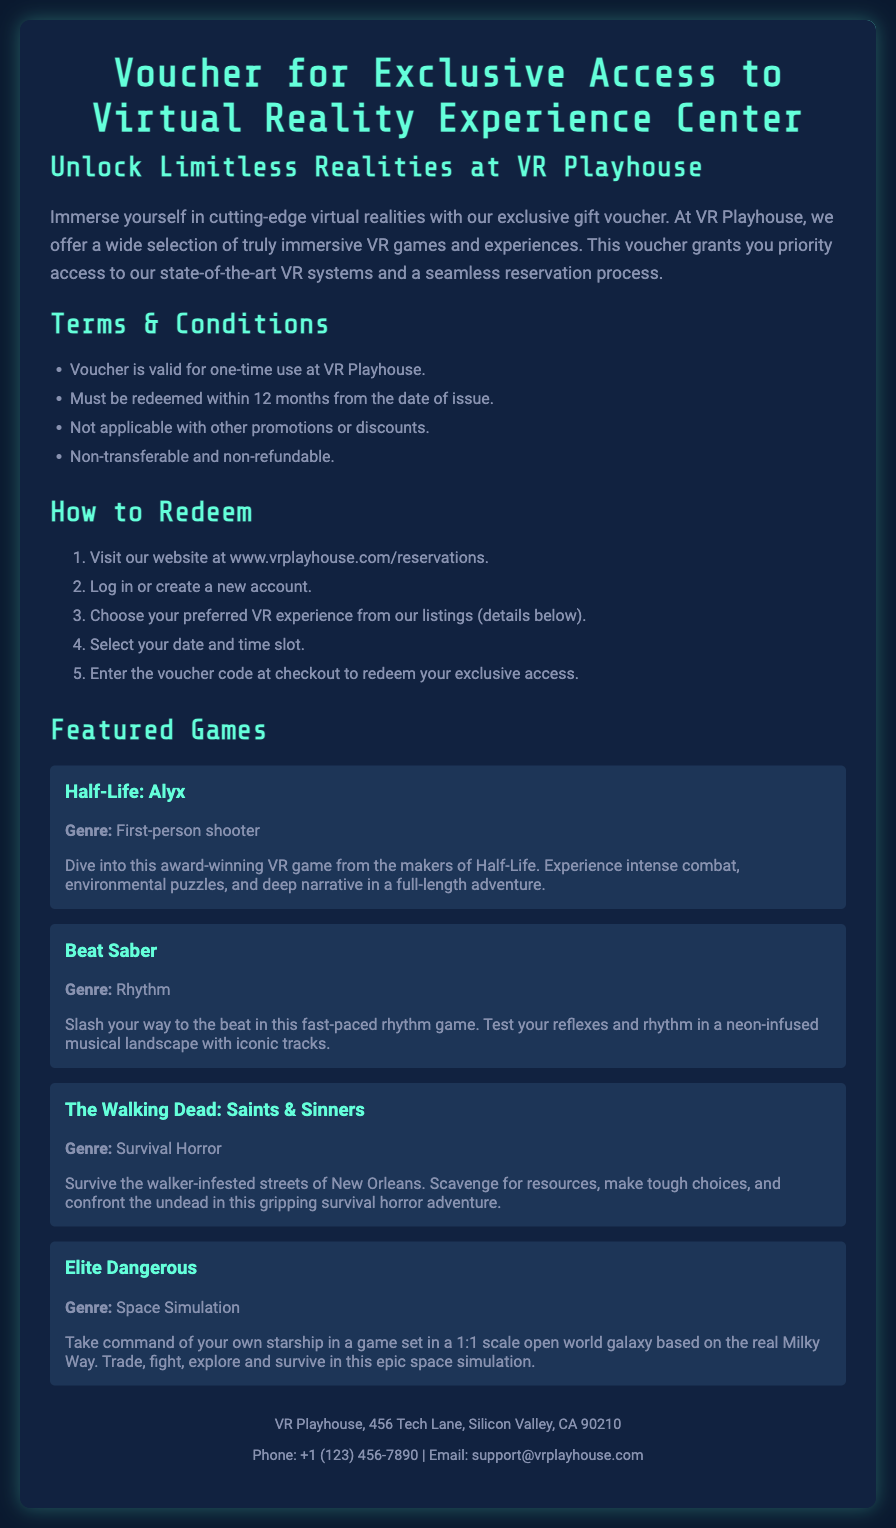What is the name of the VR Experience Center? The name is explicitly mentioned at the top of the document as "VR Playhouse."
Answer: VR Playhouse What is the validity period of the voucher? The voucher must be redeemed within 12 months from the date of issue, which is stated in the Terms & Conditions section.
Answer: 12 months How many games are featured in the document? The document lists four featured games under the Featured Games section.
Answer: Four What is the genre of "Beat Saber"? The genre is mentioned in the description of the game section as "Rhythm."
Answer: Rhythm What is the first step to redeem the voucher? The document states the first step as visiting the website for reservations.
Answer: Visit our website at www.vrplayhouse.com/reservations Is the voucher non-transferable? The Terms & Conditions specify that the voucher is non-transferable, which is stated clearly.
Answer: Non-transferable What is the phone number for VR Playhouse? The contact information includes a phone number provided at the bottom of the document.
Answer: +1 (123) 456-7890 What type of game is "The Walking Dead: Saints & Sinners"? The document categorizes it under "Survival Horror" in the game description.
Answer: Survival Horror 